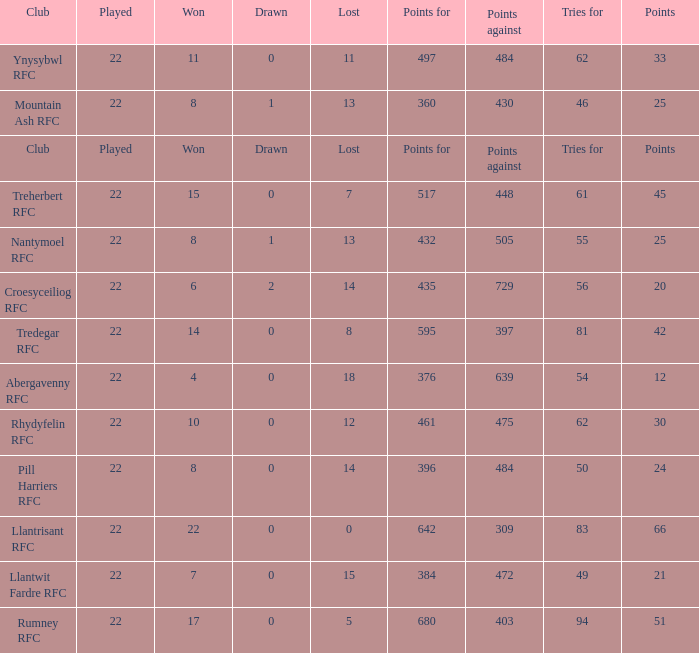For teams that won exactly 15, how many points were scored? 45.0. 